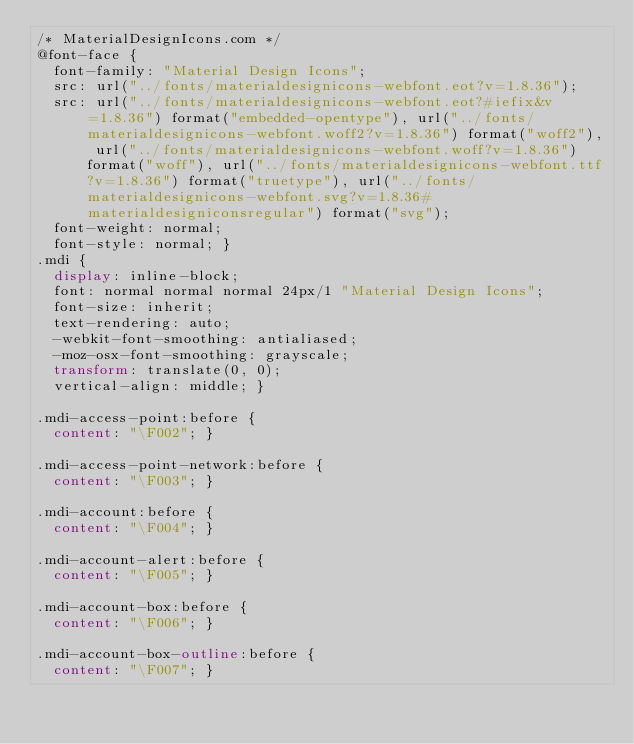<code> <loc_0><loc_0><loc_500><loc_500><_CSS_>/* MaterialDesignIcons.com */
@font-face {
  font-family: "Material Design Icons";
  src: url("../fonts/materialdesignicons-webfont.eot?v=1.8.36");
  src: url("../fonts/materialdesignicons-webfont.eot?#iefix&v=1.8.36") format("embedded-opentype"), url("../fonts/materialdesignicons-webfont.woff2?v=1.8.36") format("woff2"), url("../fonts/materialdesignicons-webfont.woff?v=1.8.36") format("woff"), url("../fonts/materialdesignicons-webfont.ttf?v=1.8.36") format("truetype"), url("../fonts/materialdesignicons-webfont.svg?v=1.8.36#materialdesigniconsregular") format("svg");
  font-weight: normal;
  font-style: normal; }
.mdi {
  display: inline-block;
  font: normal normal normal 24px/1 "Material Design Icons";
  font-size: inherit;
  text-rendering: auto;
  -webkit-font-smoothing: antialiased;
  -moz-osx-font-smoothing: grayscale;
  transform: translate(0, 0);
  vertical-align: middle; }

.mdi-access-point:before {
  content: "\F002"; }

.mdi-access-point-network:before {
  content: "\F003"; }

.mdi-account:before {
  content: "\F004"; }

.mdi-account-alert:before {
  content: "\F005"; }

.mdi-account-box:before {
  content: "\F006"; }

.mdi-account-box-outline:before {
  content: "\F007"; }
</code> 